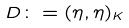Convert formula to latex. <formula><loc_0><loc_0><loc_500><loc_500>D \colon = ( \eta , \eta ) _ { K }</formula> 